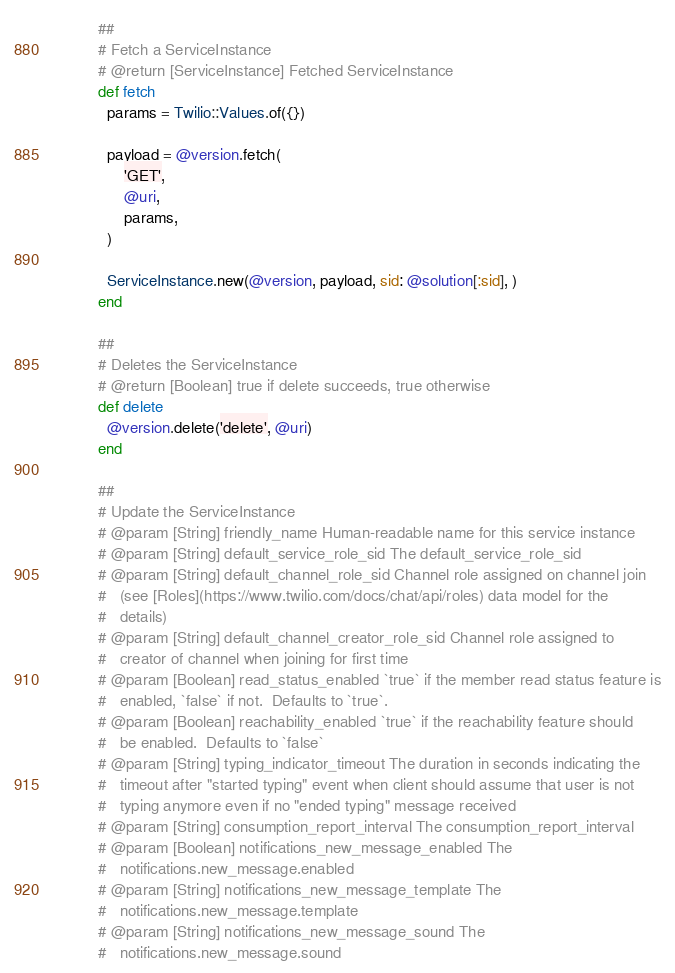Convert code to text. <code><loc_0><loc_0><loc_500><loc_500><_Ruby_>          ##
          # Fetch a ServiceInstance
          # @return [ServiceInstance] Fetched ServiceInstance
          def fetch
            params = Twilio::Values.of({})

            payload = @version.fetch(
                'GET',
                @uri,
                params,
            )

            ServiceInstance.new(@version, payload, sid: @solution[:sid], )
          end

          ##
          # Deletes the ServiceInstance
          # @return [Boolean] true if delete succeeds, true otherwise
          def delete
            @version.delete('delete', @uri)
          end

          ##
          # Update the ServiceInstance
          # @param [String] friendly_name Human-readable name for this service instance
          # @param [String] default_service_role_sid The default_service_role_sid
          # @param [String] default_channel_role_sid Channel role assigned on channel join
          #   (see [Roles](https://www.twilio.com/docs/chat/api/roles) data model for the
          #   details)
          # @param [String] default_channel_creator_role_sid Channel role assigned to
          #   creator of channel when joining for first time
          # @param [Boolean] read_status_enabled `true` if the member read status feature is
          #   enabled, `false` if not.  Defaults to `true`.
          # @param [Boolean] reachability_enabled `true` if the reachability feature should
          #   be enabled.  Defaults to `false`
          # @param [String] typing_indicator_timeout The duration in seconds indicating the
          #   timeout after "started typing" event when client should assume that user is not
          #   typing anymore even if no "ended typing" message received
          # @param [String] consumption_report_interval The consumption_report_interval
          # @param [Boolean] notifications_new_message_enabled The
          #   notifications.new_message.enabled
          # @param [String] notifications_new_message_template The
          #   notifications.new_message.template
          # @param [String] notifications_new_message_sound The
          #   notifications.new_message.sound</code> 